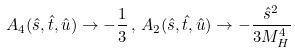<formula> <loc_0><loc_0><loc_500><loc_500>A _ { 4 } ( \hat { s } , \hat { t } , \hat { u } ) \rightarrow - \frac { 1 } { 3 } \, , \, A _ { 2 } ( \hat { s } , \hat { t } , \hat { u } ) \rightarrow - \frac { \hat { s } ^ { 2 } } { 3 M _ { H } ^ { 4 } }</formula> 